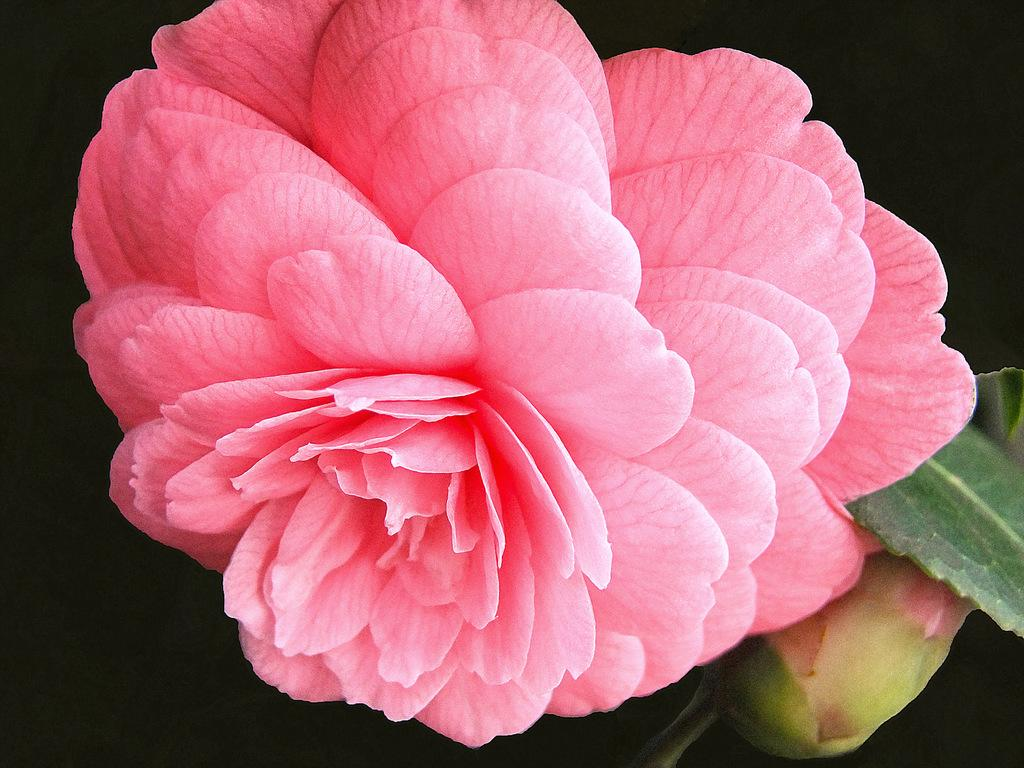What type of flower is present in the image? There is a pink flower in the image. What is the stage of development of the other flower in the image? There is a green bud in the image. What other plant parts can be seen in the image? There are green leaves in the image. What color is the background of the image? The background of the image is black. What type of writer is visible in the image? There is no writer present in the image; it features a pink flower, green bud, and green leaves against a black background. What type of net is used to catch the flowers in the image? There is no net present in the image, and flowers are not being caught. 